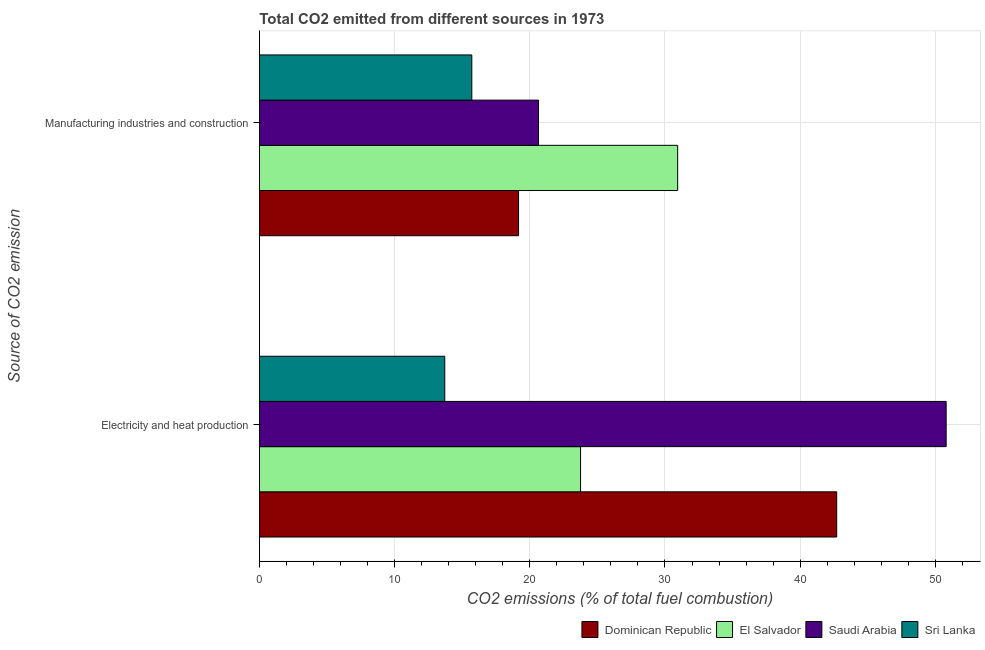Are the number of bars per tick equal to the number of legend labels?
Your answer should be compact. Yes. Are the number of bars on each tick of the Y-axis equal?
Keep it short and to the point. Yes. How many bars are there on the 1st tick from the top?
Offer a terse response. 4. How many bars are there on the 2nd tick from the bottom?
Ensure brevity in your answer.  4. What is the label of the 2nd group of bars from the top?
Make the answer very short. Electricity and heat production. What is the co2 emissions due to manufacturing industries in Sri Lanka?
Your response must be concise. 15.71. Across all countries, what is the maximum co2 emissions due to manufacturing industries?
Your response must be concise. 30.94. Across all countries, what is the minimum co2 emissions due to manufacturing industries?
Make the answer very short. 15.71. In which country was the co2 emissions due to manufacturing industries maximum?
Make the answer very short. El Salvador. In which country was the co2 emissions due to manufacturing industries minimum?
Give a very brief answer. Sri Lanka. What is the total co2 emissions due to manufacturing industries in the graph?
Ensure brevity in your answer.  86.47. What is the difference between the co2 emissions due to electricity and heat production in Saudi Arabia and that in Dominican Republic?
Ensure brevity in your answer.  8.09. What is the difference between the co2 emissions due to electricity and heat production in Sri Lanka and the co2 emissions due to manufacturing industries in El Salvador?
Make the answer very short. -17.22. What is the average co2 emissions due to electricity and heat production per country?
Your response must be concise. 32.74. What is the difference between the co2 emissions due to manufacturing industries and co2 emissions due to electricity and heat production in Dominican Republic?
Your answer should be compact. -23.53. In how many countries, is the co2 emissions due to electricity and heat production greater than 22 %?
Keep it short and to the point. 3. What is the ratio of the co2 emissions due to electricity and heat production in Sri Lanka to that in El Salvador?
Your response must be concise. 0.58. Is the co2 emissions due to electricity and heat production in Dominican Republic less than that in El Salvador?
Provide a succinct answer. No. In how many countries, is the co2 emissions due to electricity and heat production greater than the average co2 emissions due to electricity and heat production taken over all countries?
Make the answer very short. 2. What does the 4th bar from the top in Electricity and heat production represents?
Your answer should be compact. Dominican Republic. What does the 4th bar from the bottom in Electricity and heat production represents?
Your response must be concise. Sri Lanka. How many legend labels are there?
Make the answer very short. 4. How are the legend labels stacked?
Offer a very short reply. Horizontal. What is the title of the graph?
Offer a very short reply. Total CO2 emitted from different sources in 1973. Does "Israel" appear as one of the legend labels in the graph?
Offer a terse response. No. What is the label or title of the X-axis?
Your answer should be very brief. CO2 emissions (% of total fuel combustion). What is the label or title of the Y-axis?
Your answer should be very brief. Source of CO2 emission. What is the CO2 emissions (% of total fuel combustion) in Dominican Republic in Electricity and heat production?
Provide a succinct answer. 42.7. What is the CO2 emissions (% of total fuel combustion) of El Salvador in Electricity and heat production?
Provide a short and direct response. 23.76. What is the CO2 emissions (% of total fuel combustion) of Saudi Arabia in Electricity and heat production?
Offer a very short reply. 50.8. What is the CO2 emissions (% of total fuel combustion) of Sri Lanka in Electricity and heat production?
Provide a short and direct response. 13.71. What is the CO2 emissions (% of total fuel combustion) of Dominican Republic in Manufacturing industries and construction?
Make the answer very short. 19.17. What is the CO2 emissions (% of total fuel combustion) of El Salvador in Manufacturing industries and construction?
Provide a succinct answer. 30.94. What is the CO2 emissions (% of total fuel combustion) in Saudi Arabia in Manufacturing industries and construction?
Keep it short and to the point. 20.65. What is the CO2 emissions (% of total fuel combustion) in Sri Lanka in Manufacturing industries and construction?
Your response must be concise. 15.71. Across all Source of CO2 emission, what is the maximum CO2 emissions (% of total fuel combustion) in Dominican Republic?
Make the answer very short. 42.7. Across all Source of CO2 emission, what is the maximum CO2 emissions (% of total fuel combustion) of El Salvador?
Give a very brief answer. 30.94. Across all Source of CO2 emission, what is the maximum CO2 emissions (% of total fuel combustion) in Saudi Arabia?
Provide a short and direct response. 50.8. Across all Source of CO2 emission, what is the maximum CO2 emissions (% of total fuel combustion) in Sri Lanka?
Provide a succinct answer. 15.71. Across all Source of CO2 emission, what is the minimum CO2 emissions (% of total fuel combustion) in Dominican Republic?
Provide a short and direct response. 19.17. Across all Source of CO2 emission, what is the minimum CO2 emissions (% of total fuel combustion) of El Salvador?
Offer a very short reply. 23.76. Across all Source of CO2 emission, what is the minimum CO2 emissions (% of total fuel combustion) in Saudi Arabia?
Offer a terse response. 20.65. Across all Source of CO2 emission, what is the minimum CO2 emissions (% of total fuel combustion) of Sri Lanka?
Your answer should be very brief. 13.71. What is the total CO2 emissions (% of total fuel combustion) in Dominican Republic in the graph?
Your answer should be very brief. 61.87. What is the total CO2 emissions (% of total fuel combustion) of El Salvador in the graph?
Provide a succinct answer. 54.7. What is the total CO2 emissions (% of total fuel combustion) of Saudi Arabia in the graph?
Your answer should be compact. 71.44. What is the total CO2 emissions (% of total fuel combustion) in Sri Lanka in the graph?
Your answer should be compact. 29.43. What is the difference between the CO2 emissions (% of total fuel combustion) of Dominican Republic in Electricity and heat production and that in Manufacturing industries and construction?
Make the answer very short. 23.53. What is the difference between the CO2 emissions (% of total fuel combustion) in El Salvador in Electricity and heat production and that in Manufacturing industries and construction?
Offer a very short reply. -7.18. What is the difference between the CO2 emissions (% of total fuel combustion) of Saudi Arabia in Electricity and heat production and that in Manufacturing industries and construction?
Offer a very short reply. 30.15. What is the difference between the CO2 emissions (% of total fuel combustion) in Dominican Republic in Electricity and heat production and the CO2 emissions (% of total fuel combustion) in El Salvador in Manufacturing industries and construction?
Make the answer very short. 11.76. What is the difference between the CO2 emissions (% of total fuel combustion) in Dominican Republic in Electricity and heat production and the CO2 emissions (% of total fuel combustion) in Saudi Arabia in Manufacturing industries and construction?
Offer a terse response. 22.05. What is the difference between the CO2 emissions (% of total fuel combustion) in Dominican Republic in Electricity and heat production and the CO2 emissions (% of total fuel combustion) in Sri Lanka in Manufacturing industries and construction?
Offer a very short reply. 26.99. What is the difference between the CO2 emissions (% of total fuel combustion) of El Salvador in Electricity and heat production and the CO2 emissions (% of total fuel combustion) of Saudi Arabia in Manufacturing industries and construction?
Offer a terse response. 3.11. What is the difference between the CO2 emissions (% of total fuel combustion) of El Salvador in Electricity and heat production and the CO2 emissions (% of total fuel combustion) of Sri Lanka in Manufacturing industries and construction?
Offer a terse response. 8.04. What is the difference between the CO2 emissions (% of total fuel combustion) of Saudi Arabia in Electricity and heat production and the CO2 emissions (% of total fuel combustion) of Sri Lanka in Manufacturing industries and construction?
Your answer should be compact. 35.08. What is the average CO2 emissions (% of total fuel combustion) of Dominican Republic per Source of CO2 emission?
Your answer should be compact. 30.94. What is the average CO2 emissions (% of total fuel combustion) in El Salvador per Source of CO2 emission?
Offer a terse response. 27.35. What is the average CO2 emissions (% of total fuel combustion) of Saudi Arabia per Source of CO2 emission?
Your answer should be compact. 35.72. What is the average CO2 emissions (% of total fuel combustion) in Sri Lanka per Source of CO2 emission?
Offer a very short reply. 14.71. What is the difference between the CO2 emissions (% of total fuel combustion) of Dominican Republic and CO2 emissions (% of total fuel combustion) of El Salvador in Electricity and heat production?
Offer a terse response. 18.94. What is the difference between the CO2 emissions (% of total fuel combustion) in Dominican Republic and CO2 emissions (% of total fuel combustion) in Saudi Arabia in Electricity and heat production?
Offer a very short reply. -8.09. What is the difference between the CO2 emissions (% of total fuel combustion) in Dominican Republic and CO2 emissions (% of total fuel combustion) in Sri Lanka in Electricity and heat production?
Your answer should be compact. 28.99. What is the difference between the CO2 emissions (% of total fuel combustion) of El Salvador and CO2 emissions (% of total fuel combustion) of Saudi Arabia in Electricity and heat production?
Your answer should be compact. -27.04. What is the difference between the CO2 emissions (% of total fuel combustion) of El Salvador and CO2 emissions (% of total fuel combustion) of Sri Lanka in Electricity and heat production?
Ensure brevity in your answer.  10.04. What is the difference between the CO2 emissions (% of total fuel combustion) of Saudi Arabia and CO2 emissions (% of total fuel combustion) of Sri Lanka in Electricity and heat production?
Provide a short and direct response. 37.08. What is the difference between the CO2 emissions (% of total fuel combustion) of Dominican Republic and CO2 emissions (% of total fuel combustion) of El Salvador in Manufacturing industries and construction?
Give a very brief answer. -11.77. What is the difference between the CO2 emissions (% of total fuel combustion) in Dominican Republic and CO2 emissions (% of total fuel combustion) in Saudi Arabia in Manufacturing industries and construction?
Your response must be concise. -1.48. What is the difference between the CO2 emissions (% of total fuel combustion) of Dominican Republic and CO2 emissions (% of total fuel combustion) of Sri Lanka in Manufacturing industries and construction?
Your answer should be compact. 3.46. What is the difference between the CO2 emissions (% of total fuel combustion) in El Salvador and CO2 emissions (% of total fuel combustion) in Saudi Arabia in Manufacturing industries and construction?
Offer a terse response. 10.29. What is the difference between the CO2 emissions (% of total fuel combustion) of El Salvador and CO2 emissions (% of total fuel combustion) of Sri Lanka in Manufacturing industries and construction?
Offer a very short reply. 15.22. What is the difference between the CO2 emissions (% of total fuel combustion) of Saudi Arabia and CO2 emissions (% of total fuel combustion) of Sri Lanka in Manufacturing industries and construction?
Keep it short and to the point. 4.93. What is the ratio of the CO2 emissions (% of total fuel combustion) of Dominican Republic in Electricity and heat production to that in Manufacturing industries and construction?
Provide a succinct answer. 2.23. What is the ratio of the CO2 emissions (% of total fuel combustion) in El Salvador in Electricity and heat production to that in Manufacturing industries and construction?
Your response must be concise. 0.77. What is the ratio of the CO2 emissions (% of total fuel combustion) in Saudi Arabia in Electricity and heat production to that in Manufacturing industries and construction?
Offer a very short reply. 2.46. What is the ratio of the CO2 emissions (% of total fuel combustion) of Sri Lanka in Electricity and heat production to that in Manufacturing industries and construction?
Provide a short and direct response. 0.87. What is the difference between the highest and the second highest CO2 emissions (% of total fuel combustion) in Dominican Republic?
Keep it short and to the point. 23.53. What is the difference between the highest and the second highest CO2 emissions (% of total fuel combustion) in El Salvador?
Your answer should be very brief. 7.18. What is the difference between the highest and the second highest CO2 emissions (% of total fuel combustion) in Saudi Arabia?
Keep it short and to the point. 30.15. What is the difference between the highest and the lowest CO2 emissions (% of total fuel combustion) in Dominican Republic?
Your answer should be very brief. 23.53. What is the difference between the highest and the lowest CO2 emissions (% of total fuel combustion) in El Salvador?
Offer a very short reply. 7.18. What is the difference between the highest and the lowest CO2 emissions (% of total fuel combustion) in Saudi Arabia?
Your answer should be compact. 30.15. What is the difference between the highest and the lowest CO2 emissions (% of total fuel combustion) in Sri Lanka?
Your answer should be very brief. 2. 